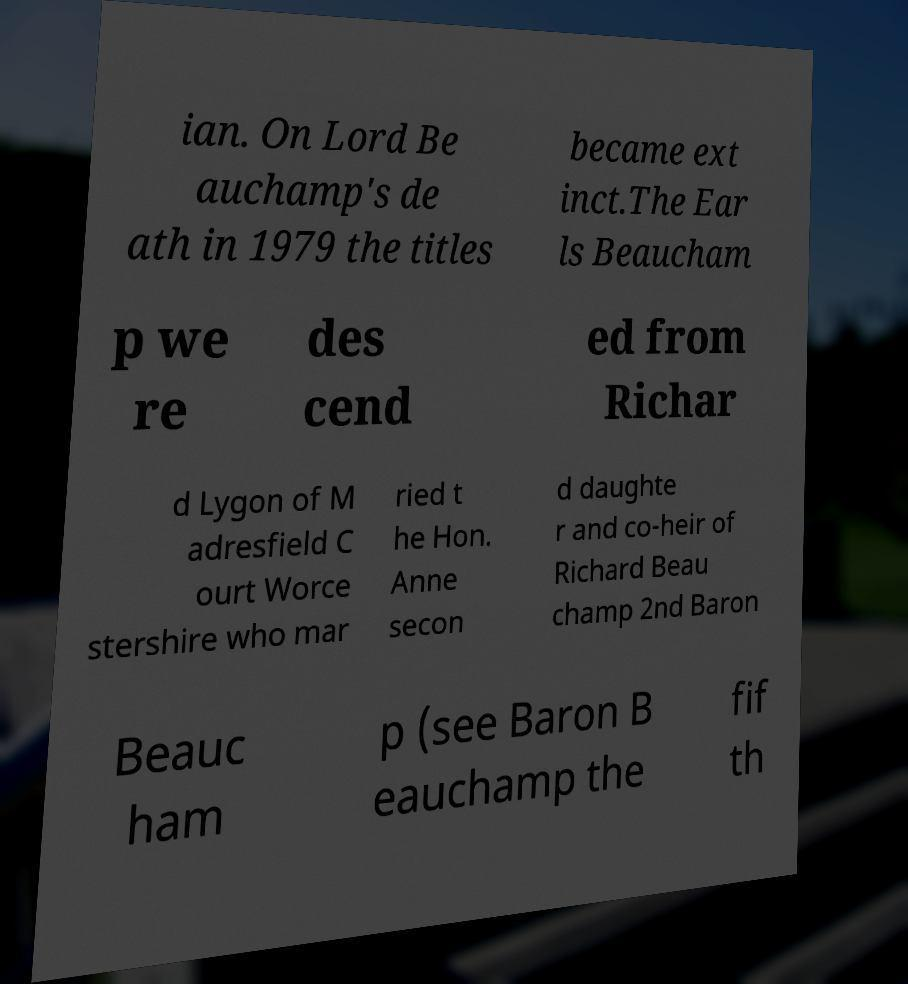Can you accurately transcribe the text from the provided image for me? ian. On Lord Be auchamp's de ath in 1979 the titles became ext inct.The Ear ls Beaucham p we re des cend ed from Richar d Lygon of M adresfield C ourt Worce stershire who mar ried t he Hon. Anne secon d daughte r and co-heir of Richard Beau champ 2nd Baron Beauc ham p (see Baron B eauchamp the fif th 